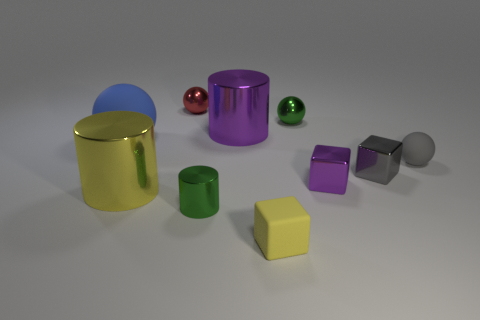What is the material of the tiny green thing that is in front of the tiny ball right of the tiny purple metallic object?
Provide a succinct answer. Metal. What shape is the blue object that is made of the same material as the gray sphere?
Make the answer very short. Sphere. Is there any other thing that has the same shape as the gray rubber object?
Your response must be concise. Yes. How many small purple cubes are in front of the blue matte sphere?
Your answer should be very brief. 1. Are there any large things?
Keep it short and to the point. Yes. The small matte thing left of the rubber ball on the right side of the tiny metal thing that is in front of the big yellow thing is what color?
Ensure brevity in your answer.  Yellow. There is a small green metal object left of the tiny matte block; is there a object that is behind it?
Provide a succinct answer. Yes. There is a cylinder that is in front of the large yellow metal cylinder; does it have the same color as the big cylinder that is in front of the gray metal cube?
Give a very brief answer. No. How many rubber blocks are the same size as the gray rubber sphere?
Offer a very short reply. 1. Do the matte sphere to the right of the purple metallic block and the yellow rubber cube have the same size?
Provide a short and direct response. Yes. 